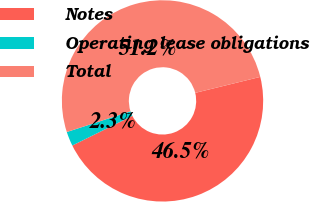Convert chart. <chart><loc_0><loc_0><loc_500><loc_500><pie_chart><fcel>Notes<fcel>Operating lease obligations<fcel>Total<nl><fcel>46.52%<fcel>2.31%<fcel>51.17%<nl></chart> 